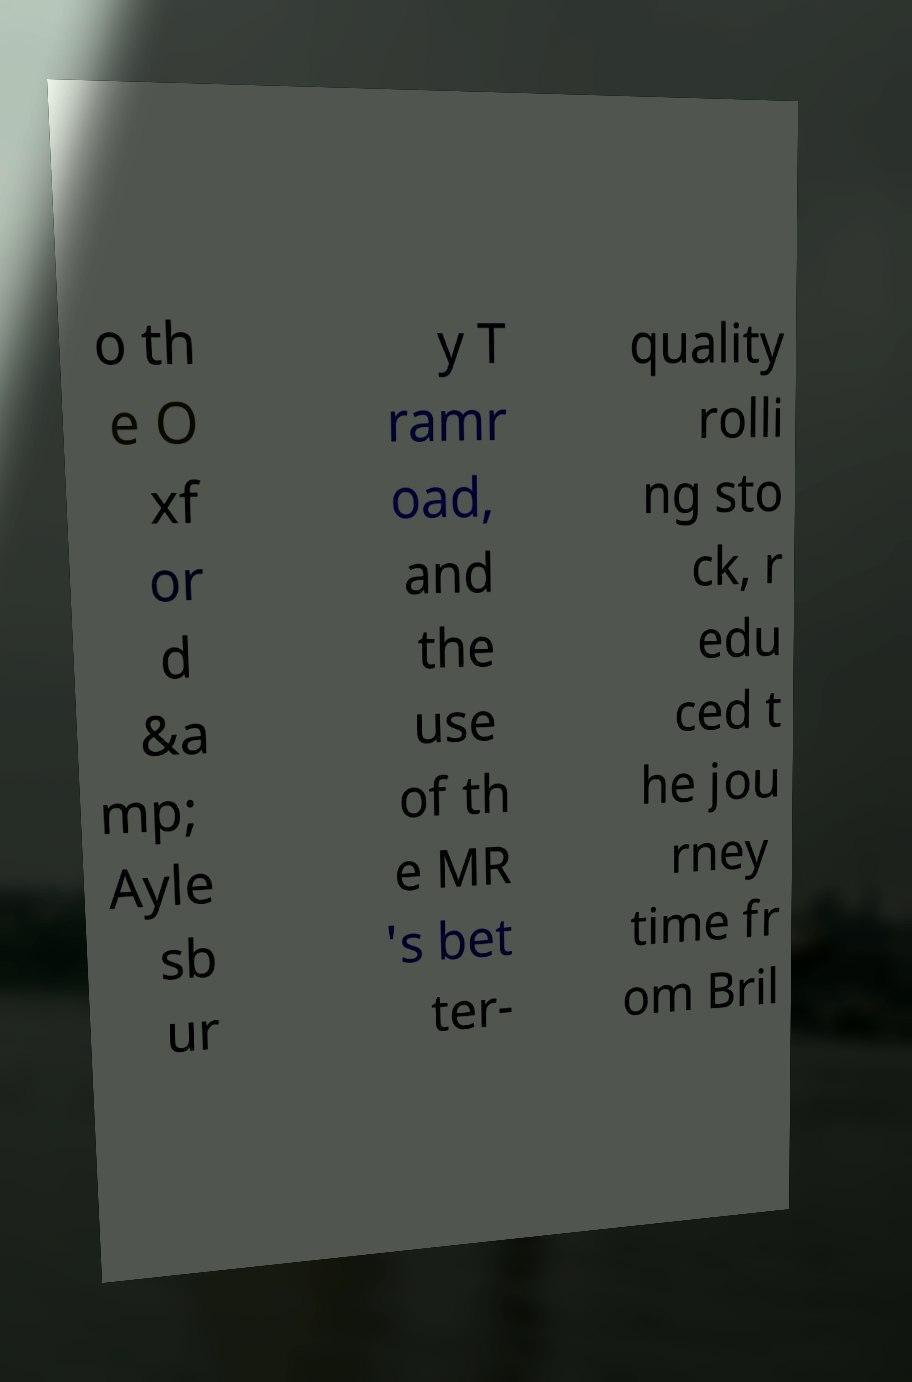Could you extract and type out the text from this image? o th e O xf or d &a mp; Ayle sb ur y T ramr oad, and the use of th e MR 's bet ter- quality rolli ng sto ck, r edu ced t he jou rney time fr om Bril 